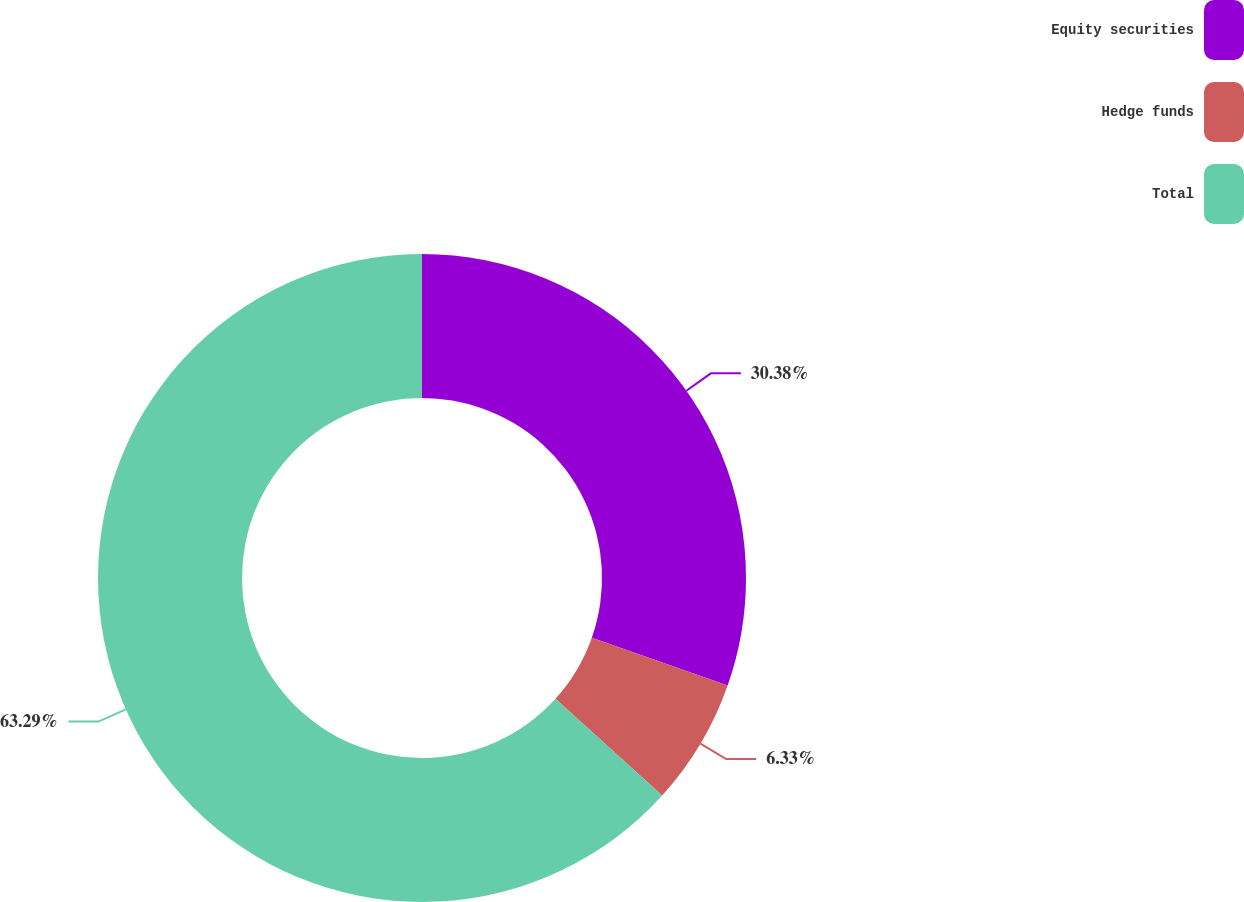<chart> <loc_0><loc_0><loc_500><loc_500><pie_chart><fcel>Equity securities<fcel>Hedge funds<fcel>Total<nl><fcel>30.38%<fcel>6.33%<fcel>63.29%<nl></chart> 